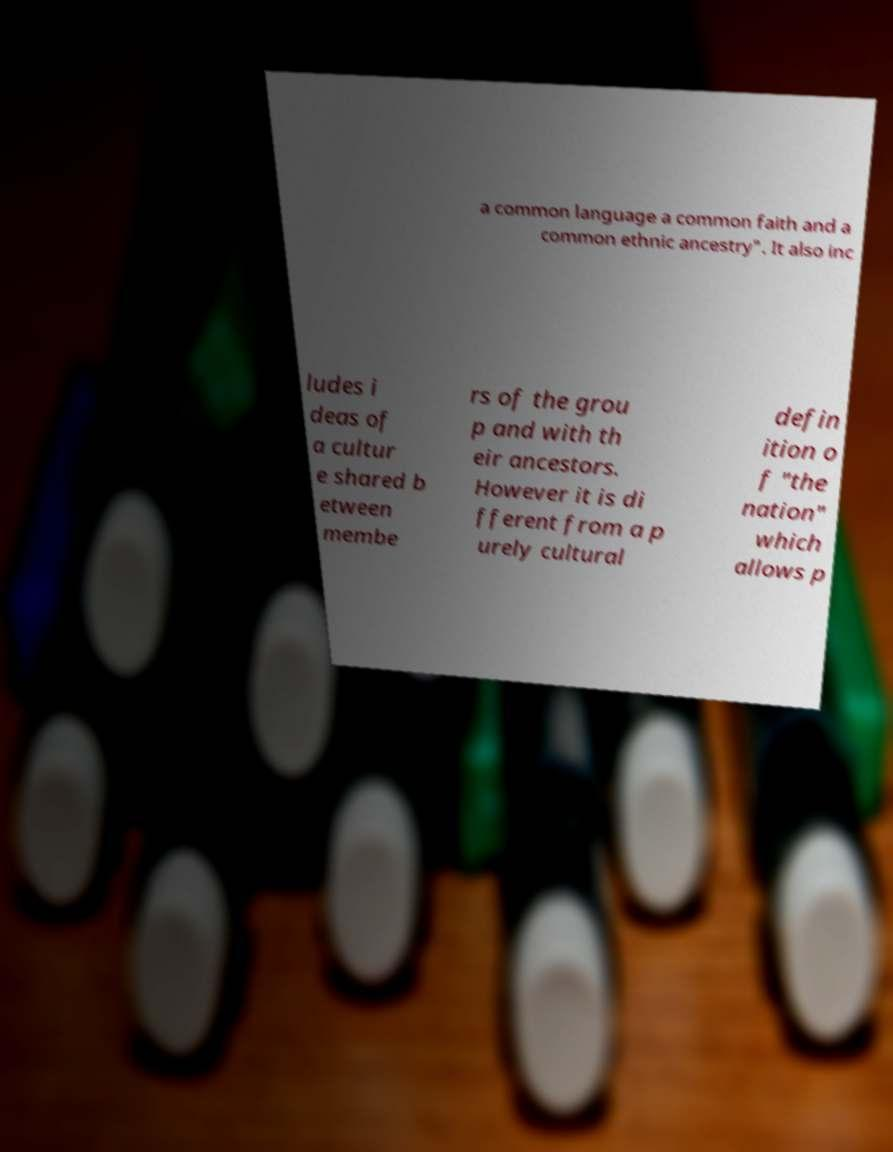There's text embedded in this image that I need extracted. Can you transcribe it verbatim? a common language a common faith and a common ethnic ancestry". It also inc ludes i deas of a cultur e shared b etween membe rs of the grou p and with th eir ancestors. However it is di fferent from a p urely cultural defin ition o f "the nation" which allows p 